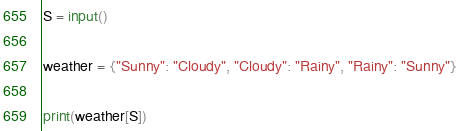Convert code to text. <code><loc_0><loc_0><loc_500><loc_500><_Python_>S = input()

weather = {"Sunny": "Cloudy", "Cloudy": "Rainy", "Rainy": "Sunny"}

print(weather[S])</code> 